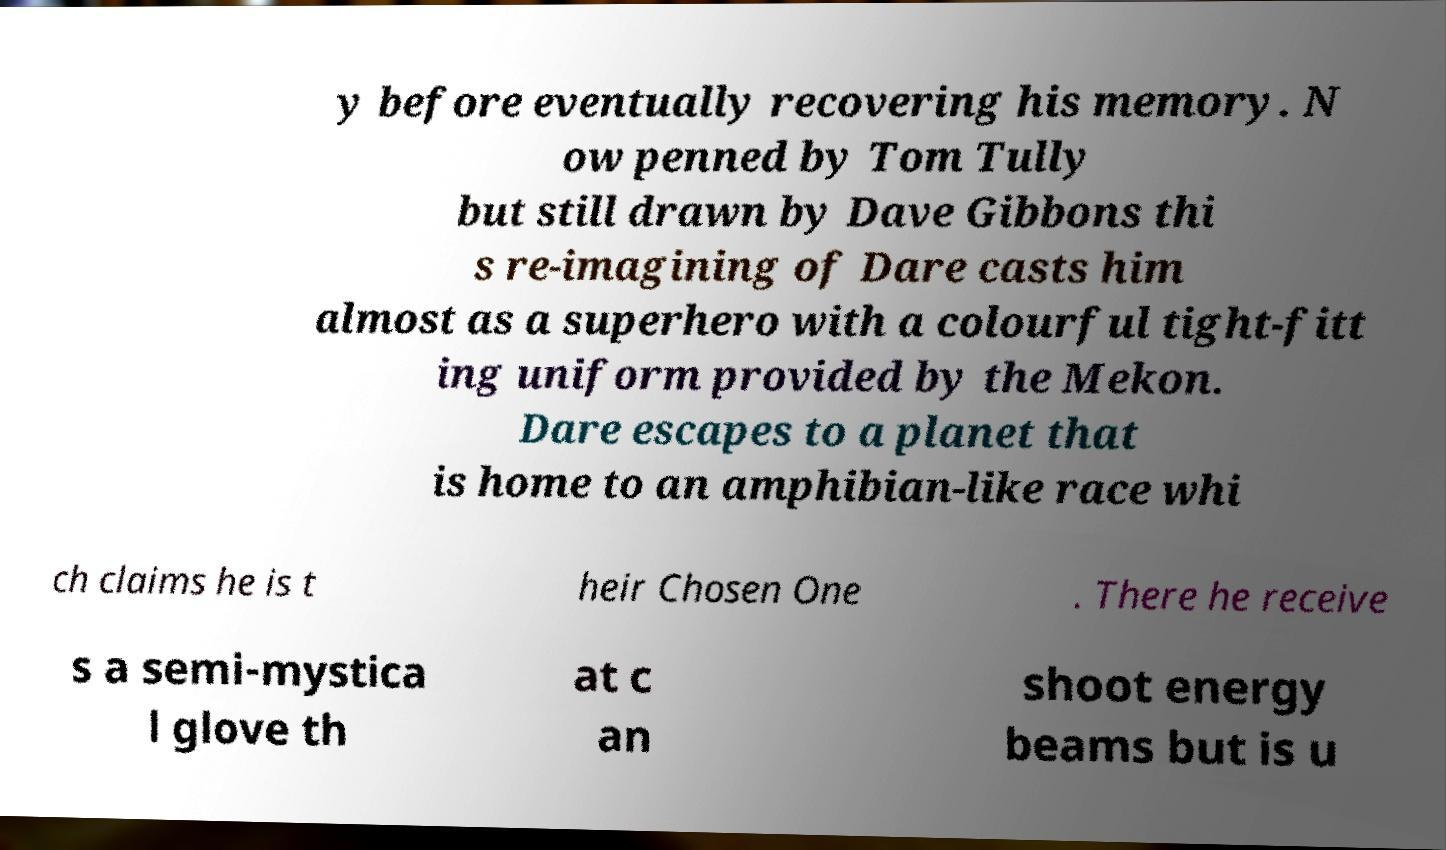What messages or text are displayed in this image? I need them in a readable, typed format. y before eventually recovering his memory. N ow penned by Tom Tully but still drawn by Dave Gibbons thi s re-imagining of Dare casts him almost as a superhero with a colourful tight-fitt ing uniform provided by the Mekon. Dare escapes to a planet that is home to an amphibian-like race whi ch claims he is t heir Chosen One . There he receive s a semi-mystica l glove th at c an shoot energy beams but is u 